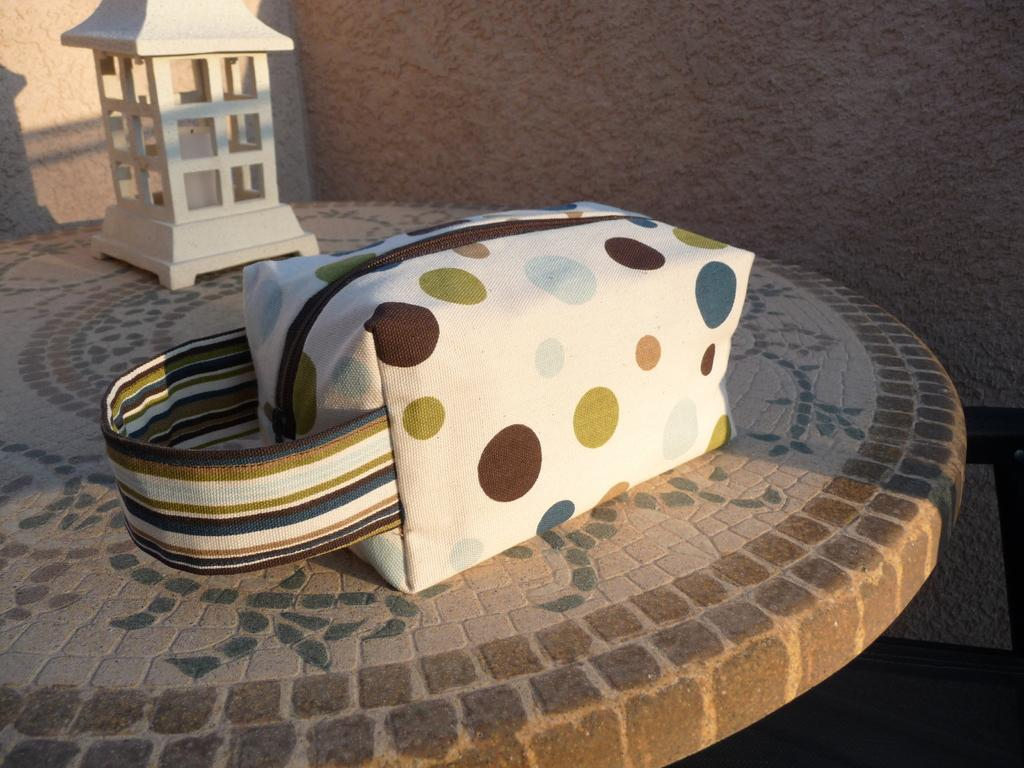What is placed on the table in the image? There is a bag on the table. What else can be seen on the table? There is a decorative item on the table. What is visible in the background of the image? There is a wall in the background of the image. What type of discussion is taking place in the image? There is no discussion taking place in the image; it only shows a bag and a decorative item on a table with a wall in the background. How much money is visible on the shelf in the image? There is no shelf or money present in the image. 